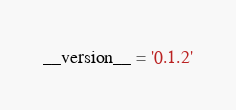<code> <loc_0><loc_0><loc_500><loc_500><_Python_>__version__ = '0.1.2'
</code> 